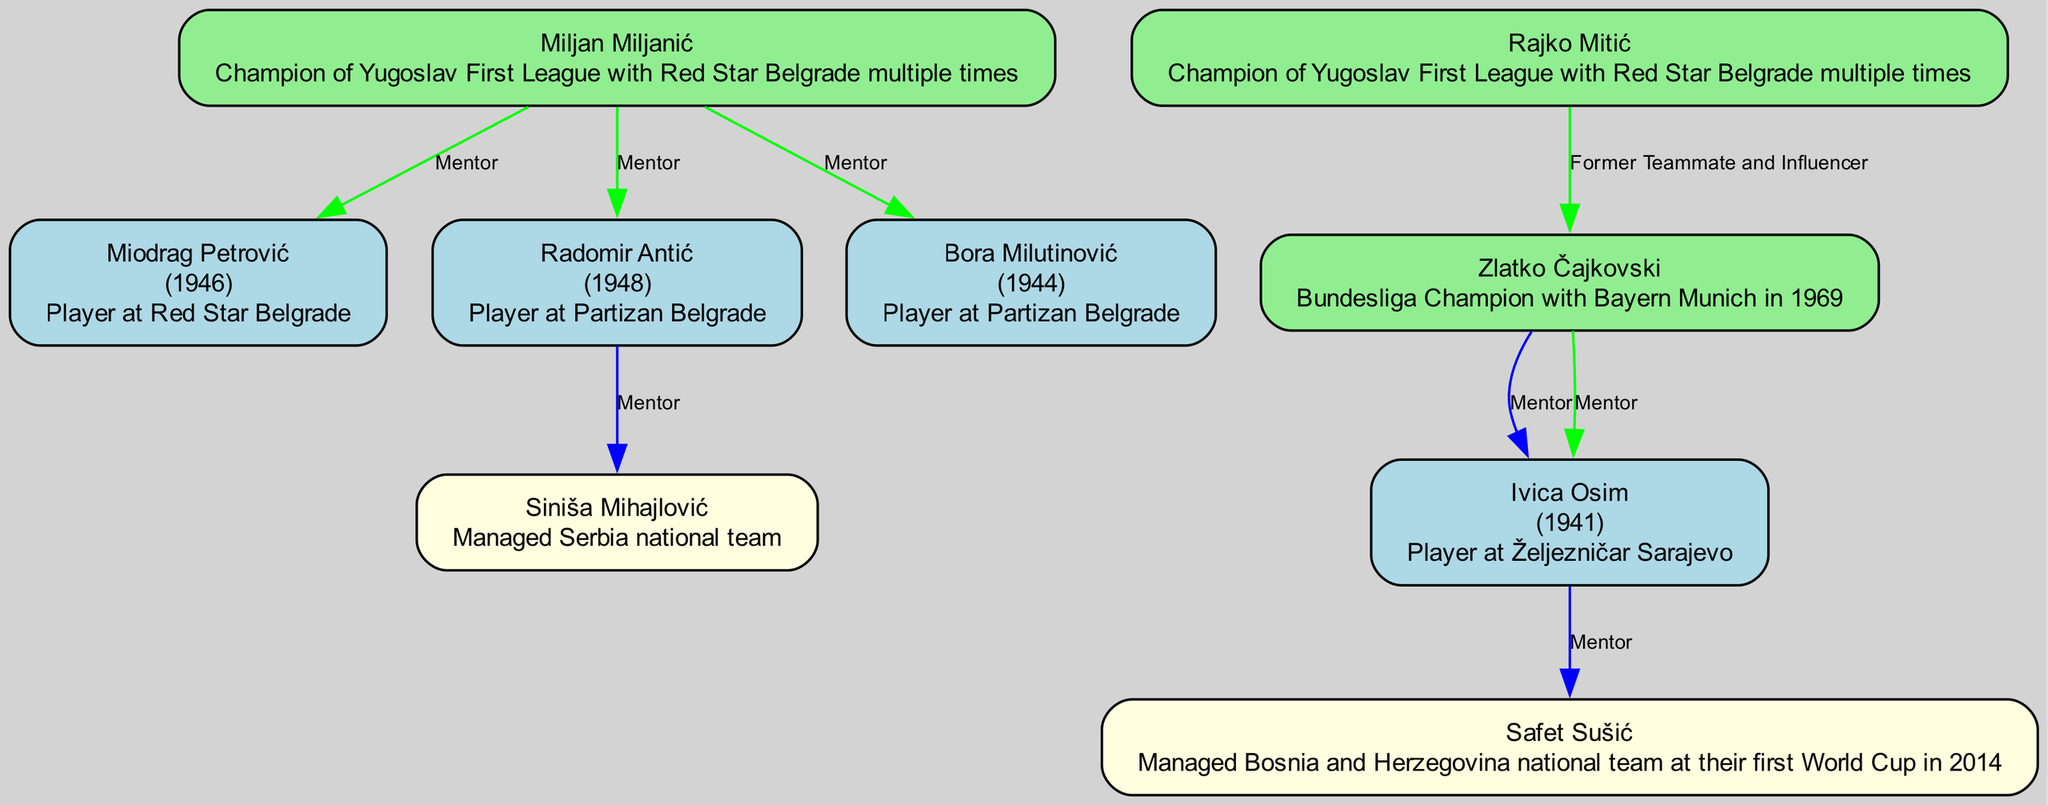What is the birth year of Miodrag Petrović? The diagram shows Miodrag Petrović with his birth year listed as 1946.
Answer: 1946 Who is a protégé of Ivica Osim? The diagram indicates that Safet Sušić is a protégé of Ivica Osim.
Answer: Safet Sušić How many managers are mentored by Miljan Miljanić? The diagram reveals that Miljan Miljanić is a mentor to three managers: Miodrag Petrović, Radomir Antić, and Bora Milutinović, totaling three.
Answer: 3 Which manager has influenced the most managers? By examining the diagram, Ivica Osim is shown to influence one manager (Safet Sušić) while Zlatko Čajkovski influences one (Ivica Osim), but Miodrag Petrović and Radomir Antić also only influence one each. This indicates a tie between the influencers, but since Ivica Osim has at least one protégé and more historical reach, he can be considered the most influential in this context.
Answer: Ivica Osim What notable achievement is associated with Bora Milutinović? The diagram states that Bora Milutinović is the only manager to lead five different national teams at the World Cup, which is his notable achievement.
Answer: Only manager to lead five different national teams at the World Cup Which player started their career at Red Star Belgrade? The diagram identifies Miodrag Petrović as the only manager who started their career as a player at Red Star Belgrade.
Answer: Miodrag Petrović Which manager was born in 1923? The diagram lists Zlatko Čajkovski with a birth year of 1923.
Answer: Zlatko Čajkovski Who influenced Ivica Osim? According to the diagram, Zlatko Čajkovski is shown as the mentor who influenced Ivica Osim.
Answer: Zlatko Čajkovski 